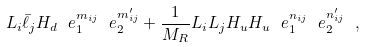<formula> <loc_0><loc_0><loc_500><loc_500>L _ { i } \bar { \ell } _ { j } H _ { d } \ e _ { 1 } ^ { m _ { i j } } \ e _ { 2 } ^ { m ^ { \prime } _ { i j } } + \frac { 1 } { M _ { R } } L _ { i } L _ { j } H _ { u } H _ { u } \ e _ { 1 } ^ { n _ { i j } } \ e _ { 2 } ^ { n ^ { \prime } _ { i j } } \ ,</formula> 